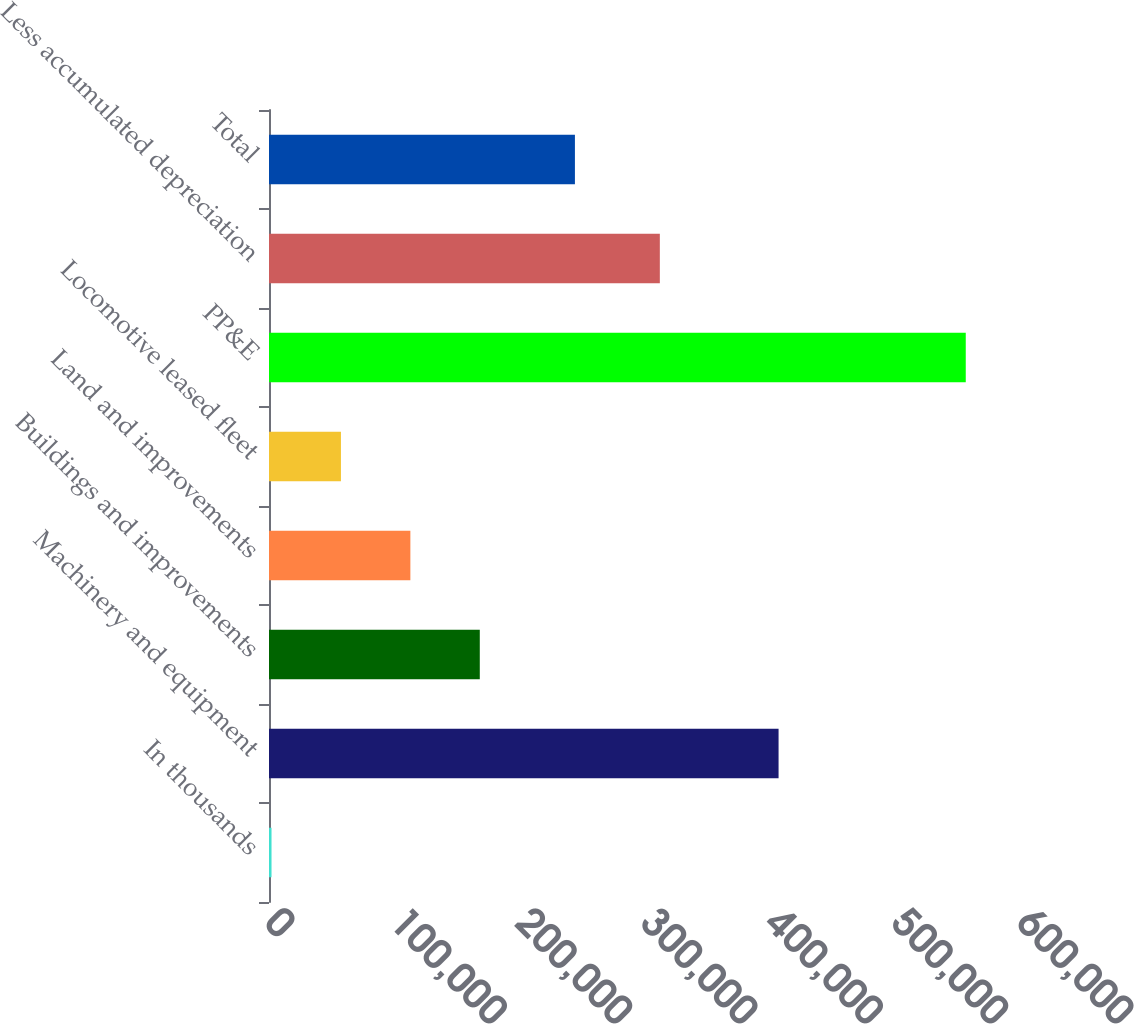<chart> <loc_0><loc_0><loc_500><loc_500><bar_chart><fcel>In thousands<fcel>Machinery and equipment<fcel>Buildings and improvements<fcel>Land and improvements<fcel>Locomotive leased fleet<fcel>PP&E<fcel>Less accumulated depreciation<fcel>Total<nl><fcel>2012<fcel>406574<fcel>168186<fcel>112794<fcel>57403.2<fcel>555924<fcel>311836<fcel>244088<nl></chart> 